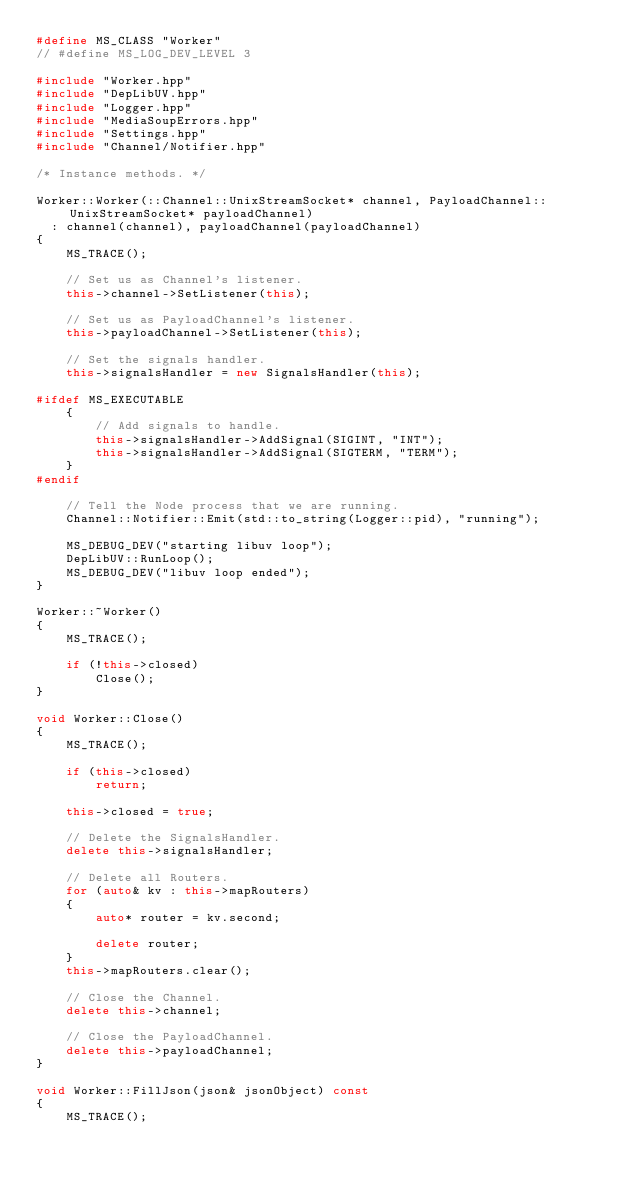<code> <loc_0><loc_0><loc_500><loc_500><_C++_>#define MS_CLASS "Worker"
// #define MS_LOG_DEV_LEVEL 3

#include "Worker.hpp"
#include "DepLibUV.hpp"
#include "Logger.hpp"
#include "MediaSoupErrors.hpp"
#include "Settings.hpp"
#include "Channel/Notifier.hpp"

/* Instance methods. */

Worker::Worker(::Channel::UnixStreamSocket* channel, PayloadChannel::UnixStreamSocket* payloadChannel)
  : channel(channel), payloadChannel(payloadChannel)
{
	MS_TRACE();

	// Set us as Channel's listener.
	this->channel->SetListener(this);

	// Set us as PayloadChannel's listener.
	this->payloadChannel->SetListener(this);

	// Set the signals handler.
	this->signalsHandler = new SignalsHandler(this);

#ifdef MS_EXECUTABLE
	{
		// Add signals to handle.
		this->signalsHandler->AddSignal(SIGINT, "INT");
		this->signalsHandler->AddSignal(SIGTERM, "TERM");
	}
#endif

	// Tell the Node process that we are running.
	Channel::Notifier::Emit(std::to_string(Logger::pid), "running");

	MS_DEBUG_DEV("starting libuv loop");
	DepLibUV::RunLoop();
	MS_DEBUG_DEV("libuv loop ended");
}

Worker::~Worker()
{
	MS_TRACE();

	if (!this->closed)
		Close();
}

void Worker::Close()
{
	MS_TRACE();

	if (this->closed)
		return;

	this->closed = true;

	// Delete the SignalsHandler.
	delete this->signalsHandler;

	// Delete all Routers.
	for (auto& kv : this->mapRouters)
	{
		auto* router = kv.second;

		delete router;
	}
	this->mapRouters.clear();

	// Close the Channel.
	delete this->channel;

	// Close the PayloadChannel.
	delete this->payloadChannel;
}

void Worker::FillJson(json& jsonObject) const
{
	MS_TRACE();
</code> 